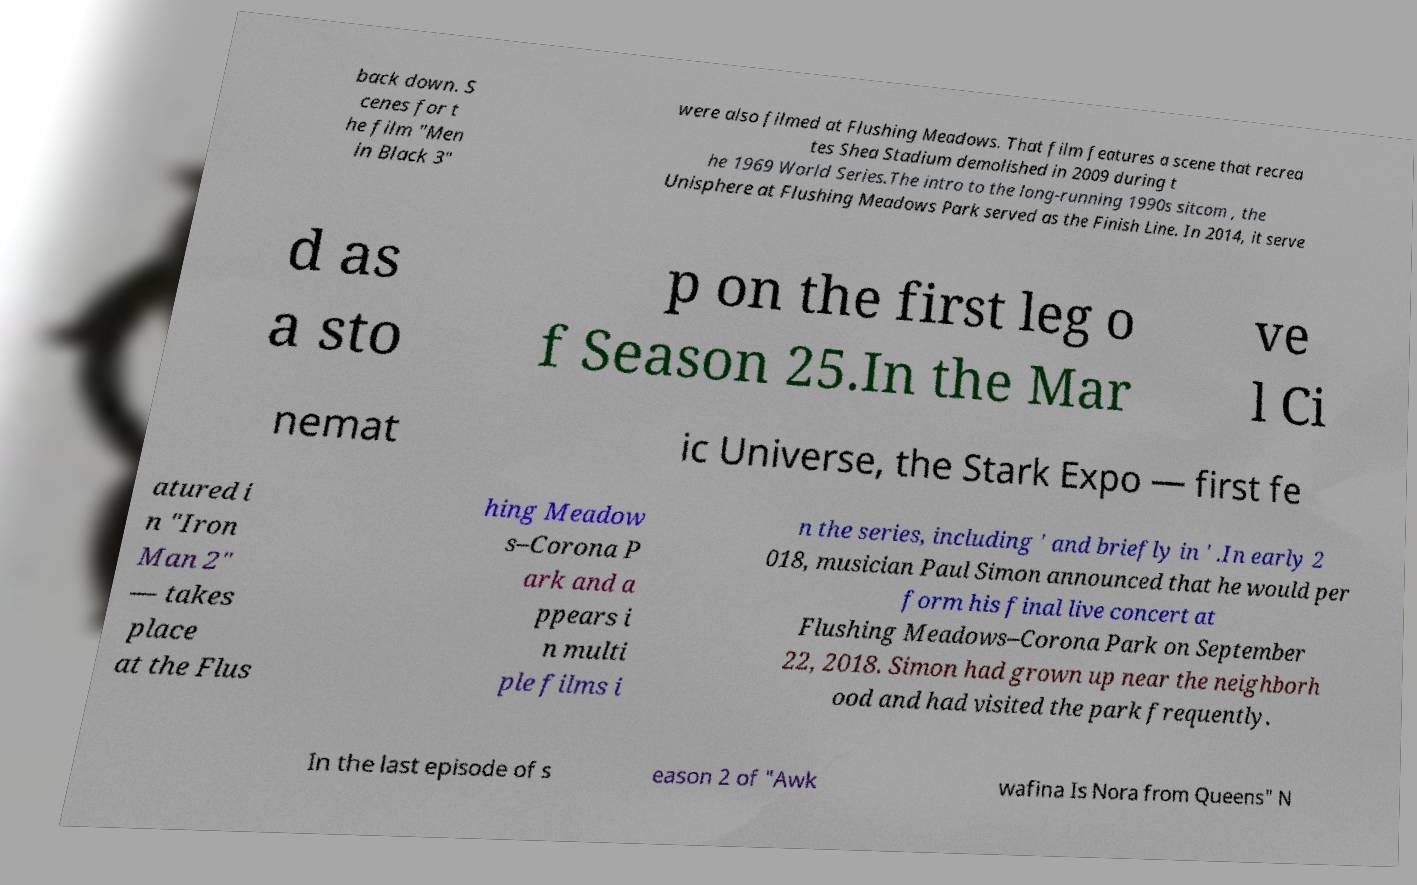Please read and relay the text visible in this image. What does it say? back down. S cenes for t he film "Men in Black 3" were also filmed at Flushing Meadows. That film features a scene that recrea tes Shea Stadium demolished in 2009 during t he 1969 World Series.The intro to the long-running 1990s sitcom , the Unisphere at Flushing Meadows Park served as the Finish Line. In 2014, it serve d as a sto p on the first leg o f Season 25.In the Mar ve l Ci nemat ic Universe, the Stark Expo — first fe atured i n "Iron Man 2" — takes place at the Flus hing Meadow s–Corona P ark and a ppears i n multi ple films i n the series, including ' and briefly in ' .In early 2 018, musician Paul Simon announced that he would per form his final live concert at Flushing Meadows–Corona Park on September 22, 2018. Simon had grown up near the neighborh ood and had visited the park frequently. In the last episode of s eason 2 of "Awk wafina Is Nora from Queens" N 